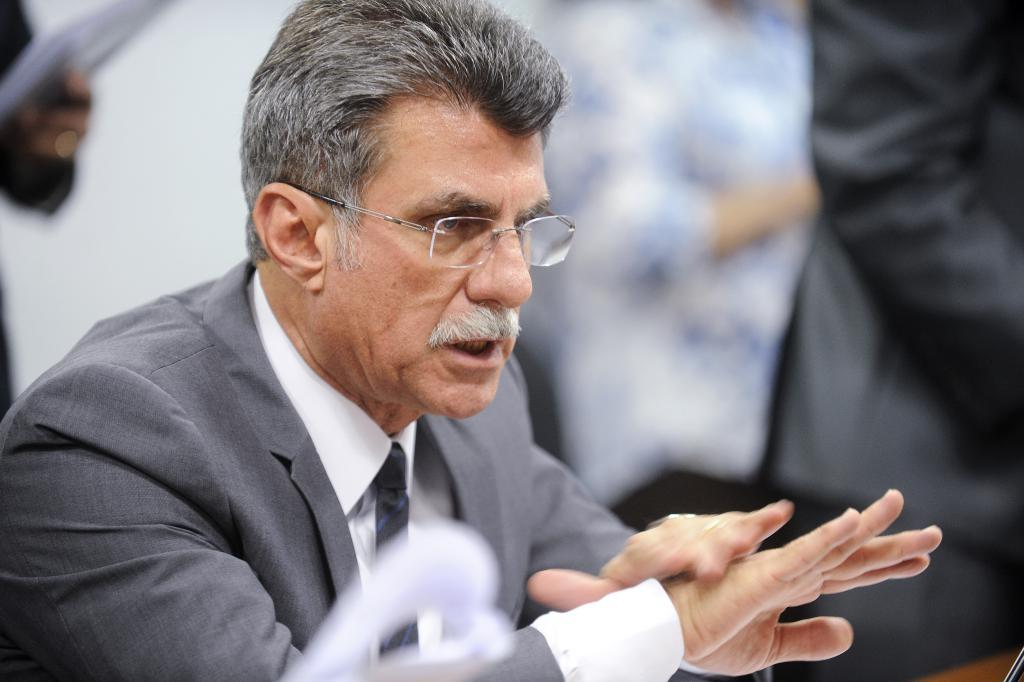What is the person in the image doing? The person is sitting in the image. What type of clothing is the person wearing on their upper body? The person is wearing a gray blazer and a white shirt. Can you describe the background of the image? The background of the image is blurred. What type of card is the person holding in the image? There is no card present in the image; the person is simply sitting and wearing a gray blazer and a white shirt. Is the person wearing a scarf in the image? There is no mention of a scarf in the provided facts, and the image does not show the person wearing a scarf. 